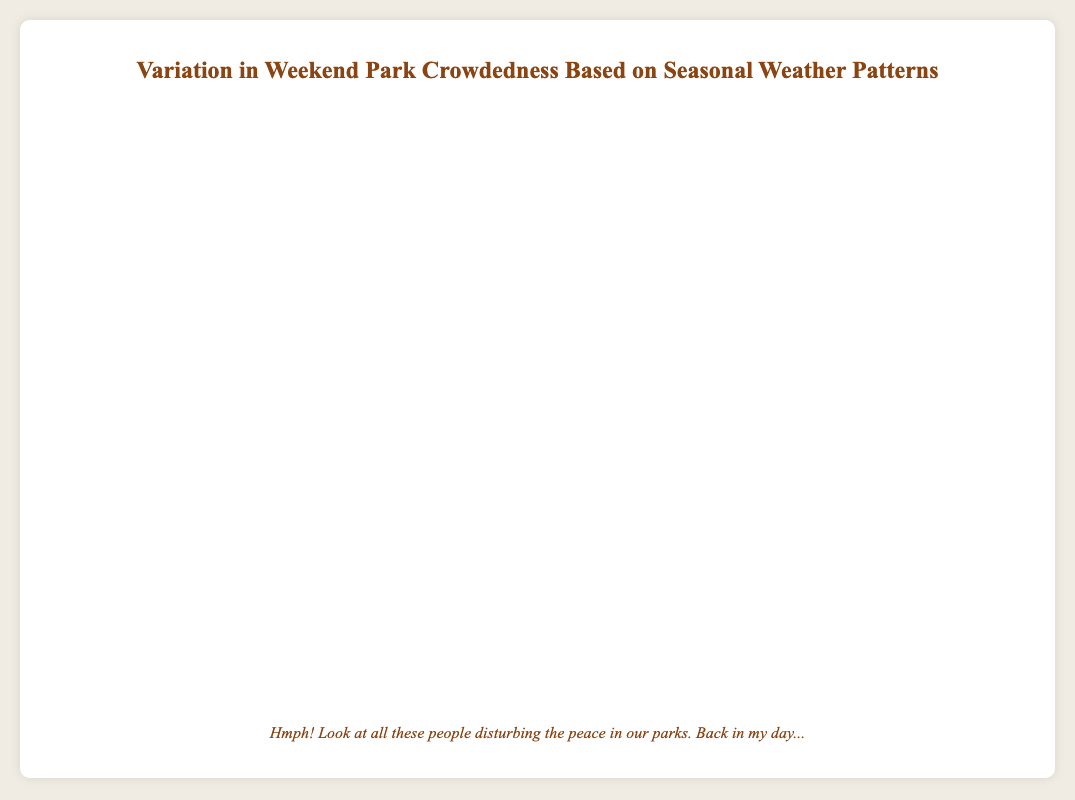What's the difference in average visitors between the sunniest day in Summer and the snowiest day in Winter? The sunniest day in Summer had 900 visitors (Balboa Park) and the snowiest day in Winter had 150 visitors (Central Park). Thus, the difference is 900 - 150 = 750
Answer: 750 Which season had the highest average visitors on a rainy day? To identify this, we need to look at the average visitors on rainy days for each season. For Spring: 250 (Golden Gate Park), Summer: 450 (Millennium Park), Autumn: 280 (Hyde Park). Spring's 250 visitors is less than Summer's 450 visitors but more than Autumn's 280 visitors. So, Summer had the highest average visitors on rainy days.
Answer: Summer During the Autumn season, which park had the highest average visitors and how many more were there compared to the park with the lowest average visitors? In Autumn, Zilker Park (550) had more visitors compared to Prospect Park (400) and Hyde Park (280). The highest is Zilker Park with 550 visitors and the lowest is Hyde Park with 280. The difference is 550 - 280 = 270
Answer: Zilker Park, 270 What's the average number of visitors in Winter across all weather types? Winter has three data points: Snowy (150), Sunny (300), and Cloudy (200). The average is calculated as (150 + 300 + 200) / 3 = 650 / 3 = 216.67
Answer: 216.67 In which weather condition did Grant Park have the maximum visitors, and what was that number? Grant Park has data for Sunny (600) and Cloudy (700). The maximum visitors were under Cloudy weather with 700 visitors
Answer: Cloudy, 700 Does any park appear in more than one season? If so, which one(s) and in which seasons? Central Park appears in Winter (Snowy and Cloudy), Golden Gate Park in Spring (Rainy and Cloudy), and Hyde Park in Winter (Sunny) and in Autumn (Rainy). Therefore, Central Park and Golden Gate Park appear in more than one season, which are Winter and Spring, respectively
Answer: Central Park: Winter, Golden Gate Park: Spring, Hyde Park: Winter and Autumn 